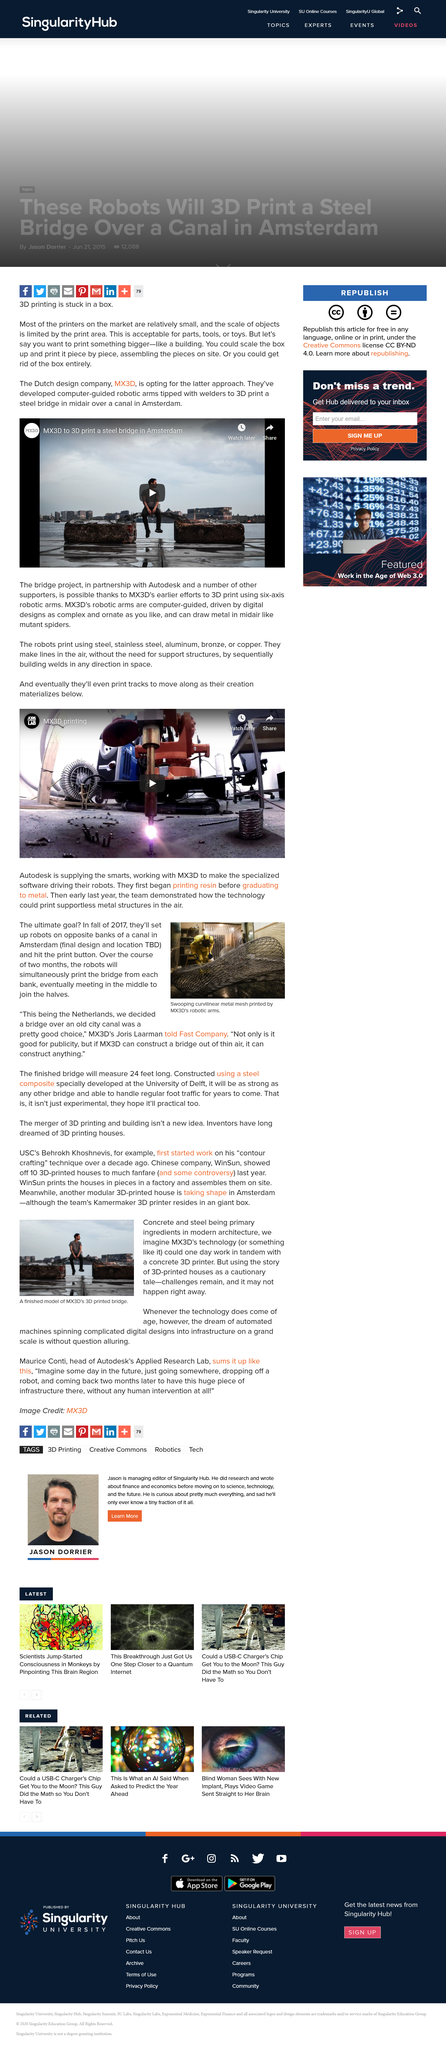Point out several critical features in this image. Mx3D's robotic printing technology will print a bridge over the course of two months, joining the two banks in the middle, and will be a great publicity stunt for the company's capabilities. The ultimate goal is to set up two robots on opposite banks of a canal in Amsterdam and initiate the print process by hitting the print button in Fall 2017. MX3D is the name of the Dutch design company that is known for its innovative and cutting-edge approach to design. It is a company that is widely recognized for its contributions to the field of design and is highly respected within the industry. The name MX3D has become synonymous with excellence in design, and the company continues to push the boundaries of what is possible through its groundbreaking work. In modern architecture, concrete and steel are the primary ingredients that are consistently utilized to create structures that are both functional and aesthetically pleasing. MX3D is choosing to eliminate the box altogether. 